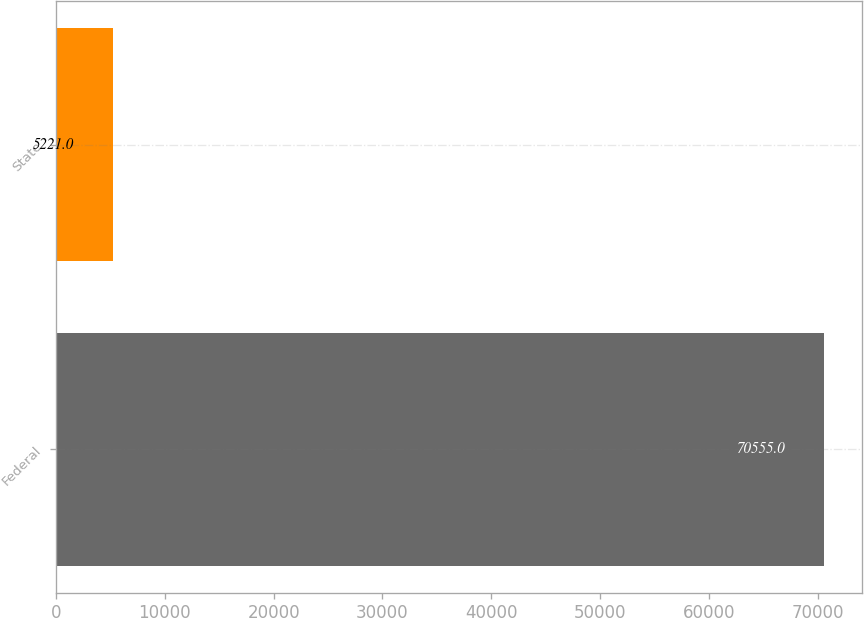Convert chart to OTSL. <chart><loc_0><loc_0><loc_500><loc_500><bar_chart><fcel>Federal<fcel>State<nl><fcel>70555<fcel>5221<nl></chart> 